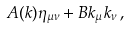<formula> <loc_0><loc_0><loc_500><loc_500>A ( k ) \eta _ { \mu \nu } + B k _ { \mu } k _ { \nu } \, ,</formula> 